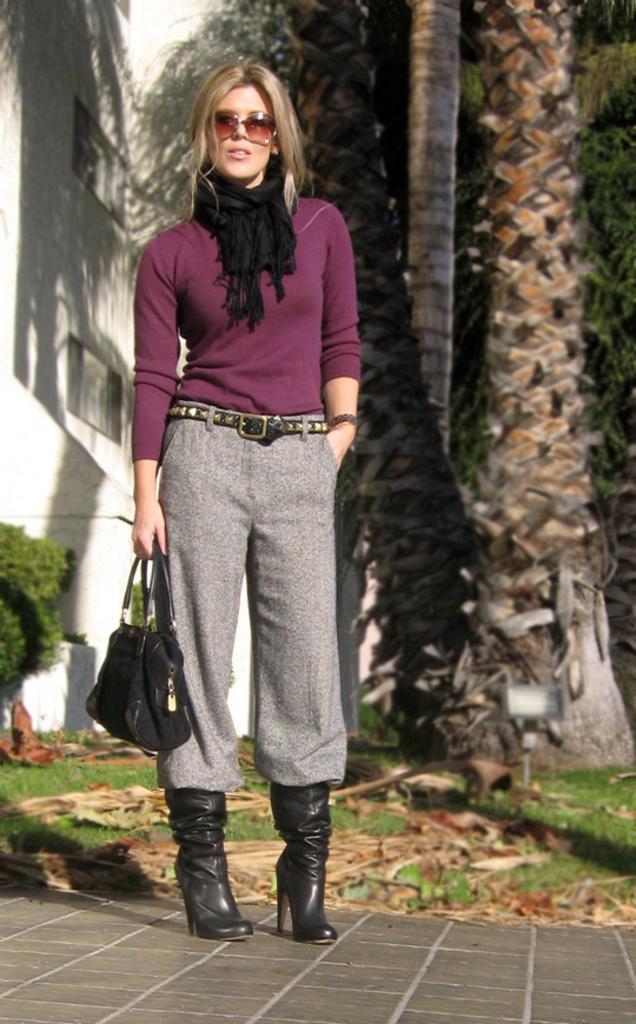How would you summarize this image in a sentence or two? There is a woman standing in a picture, holding a bag in her hand. She is wearing a maroon t shirt and a scarf around her neck. She is wearing a spectacles and shoes. Behind her there are some dry leaves and trees here. There is a building in the background. 